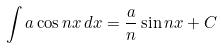<formula> <loc_0><loc_0><loc_500><loc_500>\int a \cos n x \, d x = { \frac { a } { n } } \sin n x + C</formula> 